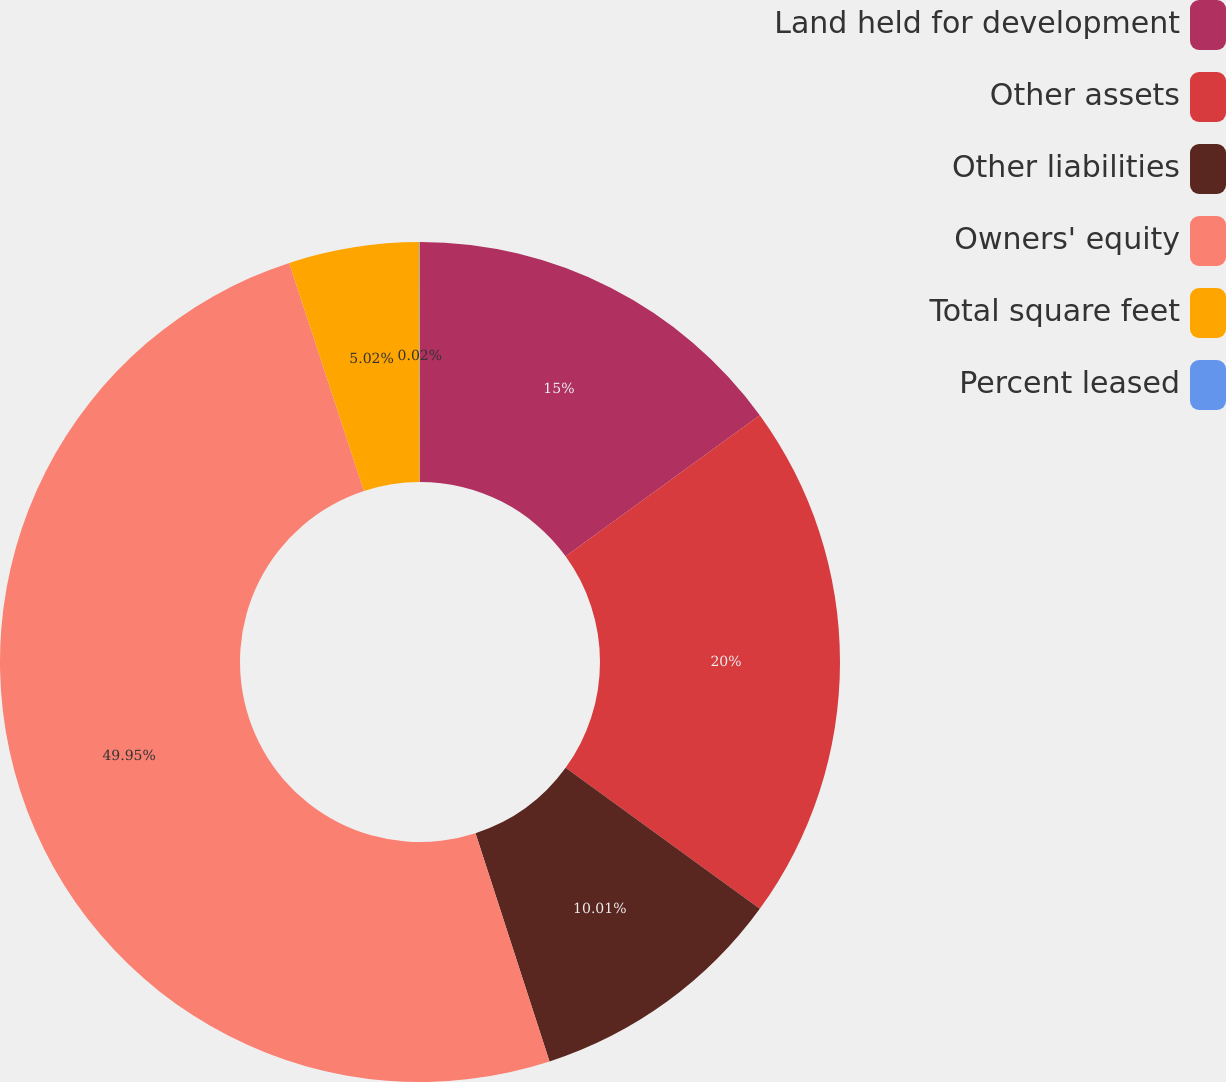Convert chart to OTSL. <chart><loc_0><loc_0><loc_500><loc_500><pie_chart><fcel>Land held for development<fcel>Other assets<fcel>Other liabilities<fcel>Owners' equity<fcel>Total square feet<fcel>Percent leased<nl><fcel>15.0%<fcel>20.0%<fcel>10.01%<fcel>49.95%<fcel>5.02%<fcel>0.02%<nl></chart> 